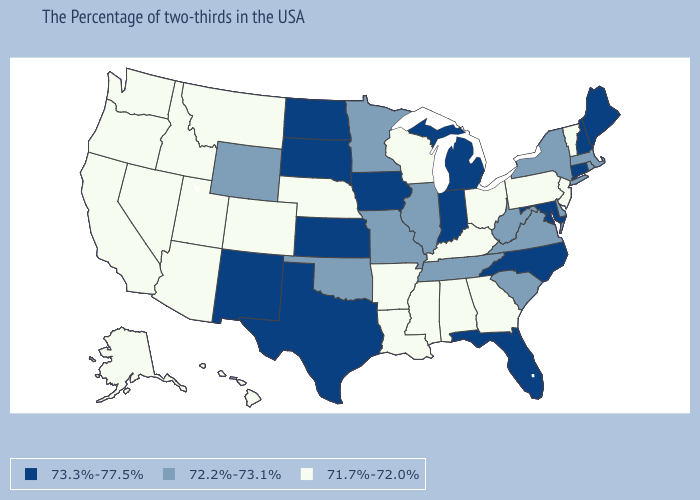Among the states that border Minnesota , does Wisconsin have the lowest value?
Be succinct. Yes. Does Florida have a higher value than Connecticut?
Short answer required. No. What is the value of South Carolina?
Be succinct. 72.2%-73.1%. What is the lowest value in states that border Kentucky?
Be succinct. 71.7%-72.0%. Which states have the highest value in the USA?
Be succinct. Maine, New Hampshire, Connecticut, Maryland, North Carolina, Florida, Michigan, Indiana, Iowa, Kansas, Texas, South Dakota, North Dakota, New Mexico. What is the value of Indiana?
Concise answer only. 73.3%-77.5%. How many symbols are there in the legend?
Write a very short answer. 3. What is the value of New Hampshire?
Quick response, please. 73.3%-77.5%. Does Ohio have the same value as Michigan?
Give a very brief answer. No. Among the states that border West Virginia , does Virginia have the lowest value?
Give a very brief answer. No. Name the states that have a value in the range 71.7%-72.0%?
Give a very brief answer. Vermont, New Jersey, Pennsylvania, Ohio, Georgia, Kentucky, Alabama, Wisconsin, Mississippi, Louisiana, Arkansas, Nebraska, Colorado, Utah, Montana, Arizona, Idaho, Nevada, California, Washington, Oregon, Alaska, Hawaii. What is the highest value in the USA?
Concise answer only. 73.3%-77.5%. What is the value of West Virginia?
Answer briefly. 72.2%-73.1%. Does the first symbol in the legend represent the smallest category?
Concise answer only. No. Among the states that border Wyoming , which have the lowest value?
Answer briefly. Nebraska, Colorado, Utah, Montana, Idaho. 